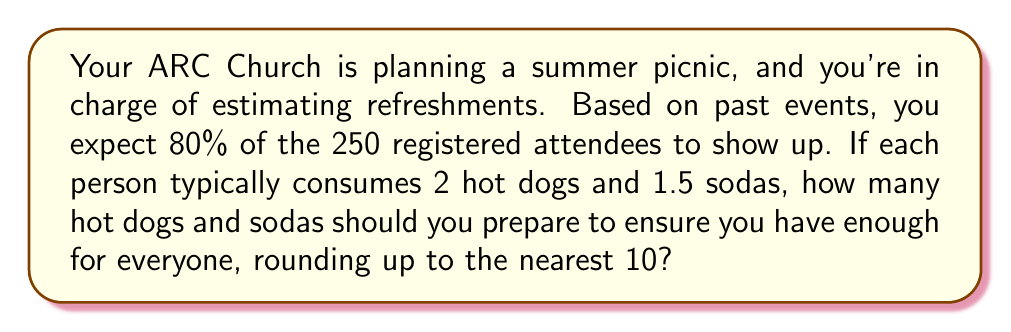Can you solve this math problem? Let's break this down step-by-step:

1. Calculate the expected number of attendees:
   $$ \text{Expected attendees} = 250 \times 80\% = 250 \times 0.8 = 200 $$

2. Calculate the number of hot dogs needed:
   $$ \text{Hot dogs} = 200 \text{ attendees} \times 2 \text{ hot dogs per person} = 400 $$

3. Calculate the number of sodas needed:
   $$ \text{Sodas} = 200 \text{ attendees} \times 1.5 \text{ sodas per person} = 300 $$

4. Round up to the nearest 10:
   Hot dogs: 400 is already a multiple of 10, so it stays at 400.
   Sodas: 300 is already a multiple of 10, so it stays at 300.

Therefore, you should prepare 400 hot dogs and 300 sodas for the picnic.
Answer: 400 hot dogs, 300 sodas 